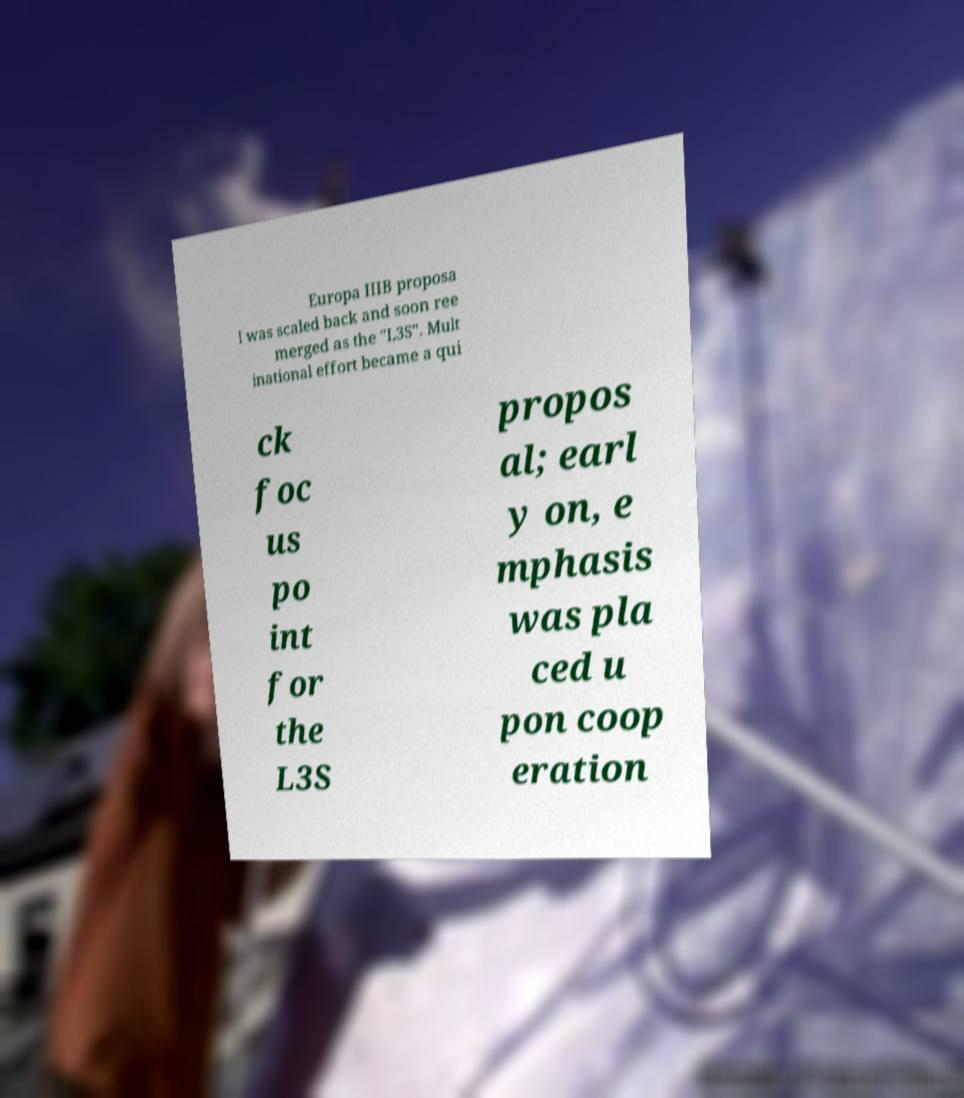Please read and relay the text visible in this image. What does it say? Europa IIIB proposa l was scaled back and soon ree merged as the "L3S". Mult inational effort became a qui ck foc us po int for the L3S propos al; earl y on, e mphasis was pla ced u pon coop eration 